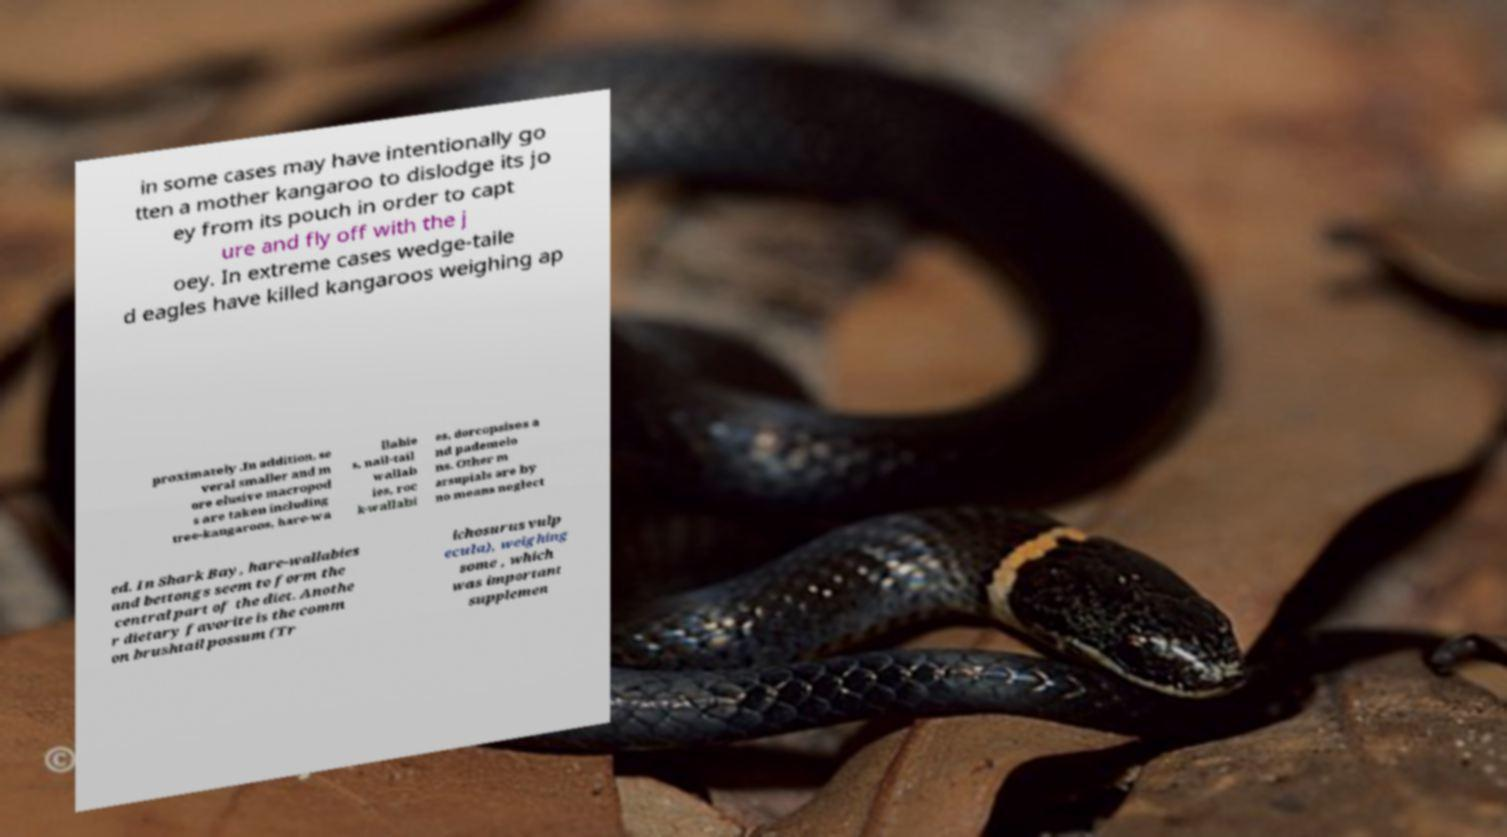Please read and relay the text visible in this image. What does it say? in some cases may have intentionally go tten a mother kangaroo to dislodge its jo ey from its pouch in order to capt ure and fly off with the j oey. In extreme cases wedge-taile d eagles have killed kangaroos weighing ap proximately .In addition, se veral smaller and m ore elusive macropod s are taken including tree-kangaroos, hare-wa llabie s, nail-tail wallab ies, roc k-wallabi es, dorcopsises a nd pademelo ns. Other m arsupials are by no means neglect ed. In Shark Bay, hare-wallabies and bettongs seem to form the central part of the diet. Anothe r dietary favorite is the comm on brushtail possum (Tr ichosurus vulp ecula), weighing some , which was important supplemen 